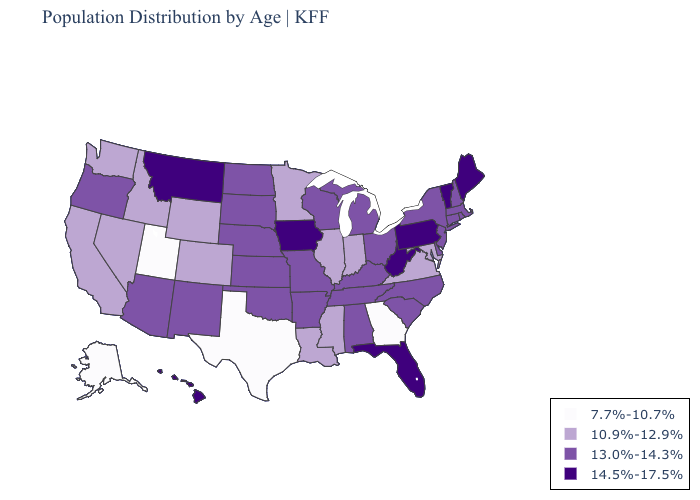Name the states that have a value in the range 13.0%-14.3%?
Be succinct. Alabama, Arizona, Arkansas, Connecticut, Delaware, Kansas, Kentucky, Massachusetts, Michigan, Missouri, Nebraska, New Hampshire, New Jersey, New Mexico, New York, North Carolina, North Dakota, Ohio, Oklahoma, Oregon, Rhode Island, South Carolina, South Dakota, Tennessee, Wisconsin. Is the legend a continuous bar?
Quick response, please. No. Does Michigan have the highest value in the MidWest?
Write a very short answer. No. Does North Carolina have the highest value in the South?
Be succinct. No. How many symbols are there in the legend?
Short answer required. 4. What is the value of Alaska?
Be succinct. 7.7%-10.7%. Does the first symbol in the legend represent the smallest category?
Concise answer only. Yes. What is the highest value in the USA?
Write a very short answer. 14.5%-17.5%. Name the states that have a value in the range 10.9%-12.9%?
Concise answer only. California, Colorado, Idaho, Illinois, Indiana, Louisiana, Maryland, Minnesota, Mississippi, Nevada, Virginia, Washington, Wyoming. Name the states that have a value in the range 10.9%-12.9%?
Write a very short answer. California, Colorado, Idaho, Illinois, Indiana, Louisiana, Maryland, Minnesota, Mississippi, Nevada, Virginia, Washington, Wyoming. Does the first symbol in the legend represent the smallest category?
Quick response, please. Yes. Name the states that have a value in the range 10.9%-12.9%?
Keep it brief. California, Colorado, Idaho, Illinois, Indiana, Louisiana, Maryland, Minnesota, Mississippi, Nevada, Virginia, Washington, Wyoming. Does the map have missing data?
Keep it brief. No. How many symbols are there in the legend?
Give a very brief answer. 4. Does the map have missing data?
Keep it brief. No. 